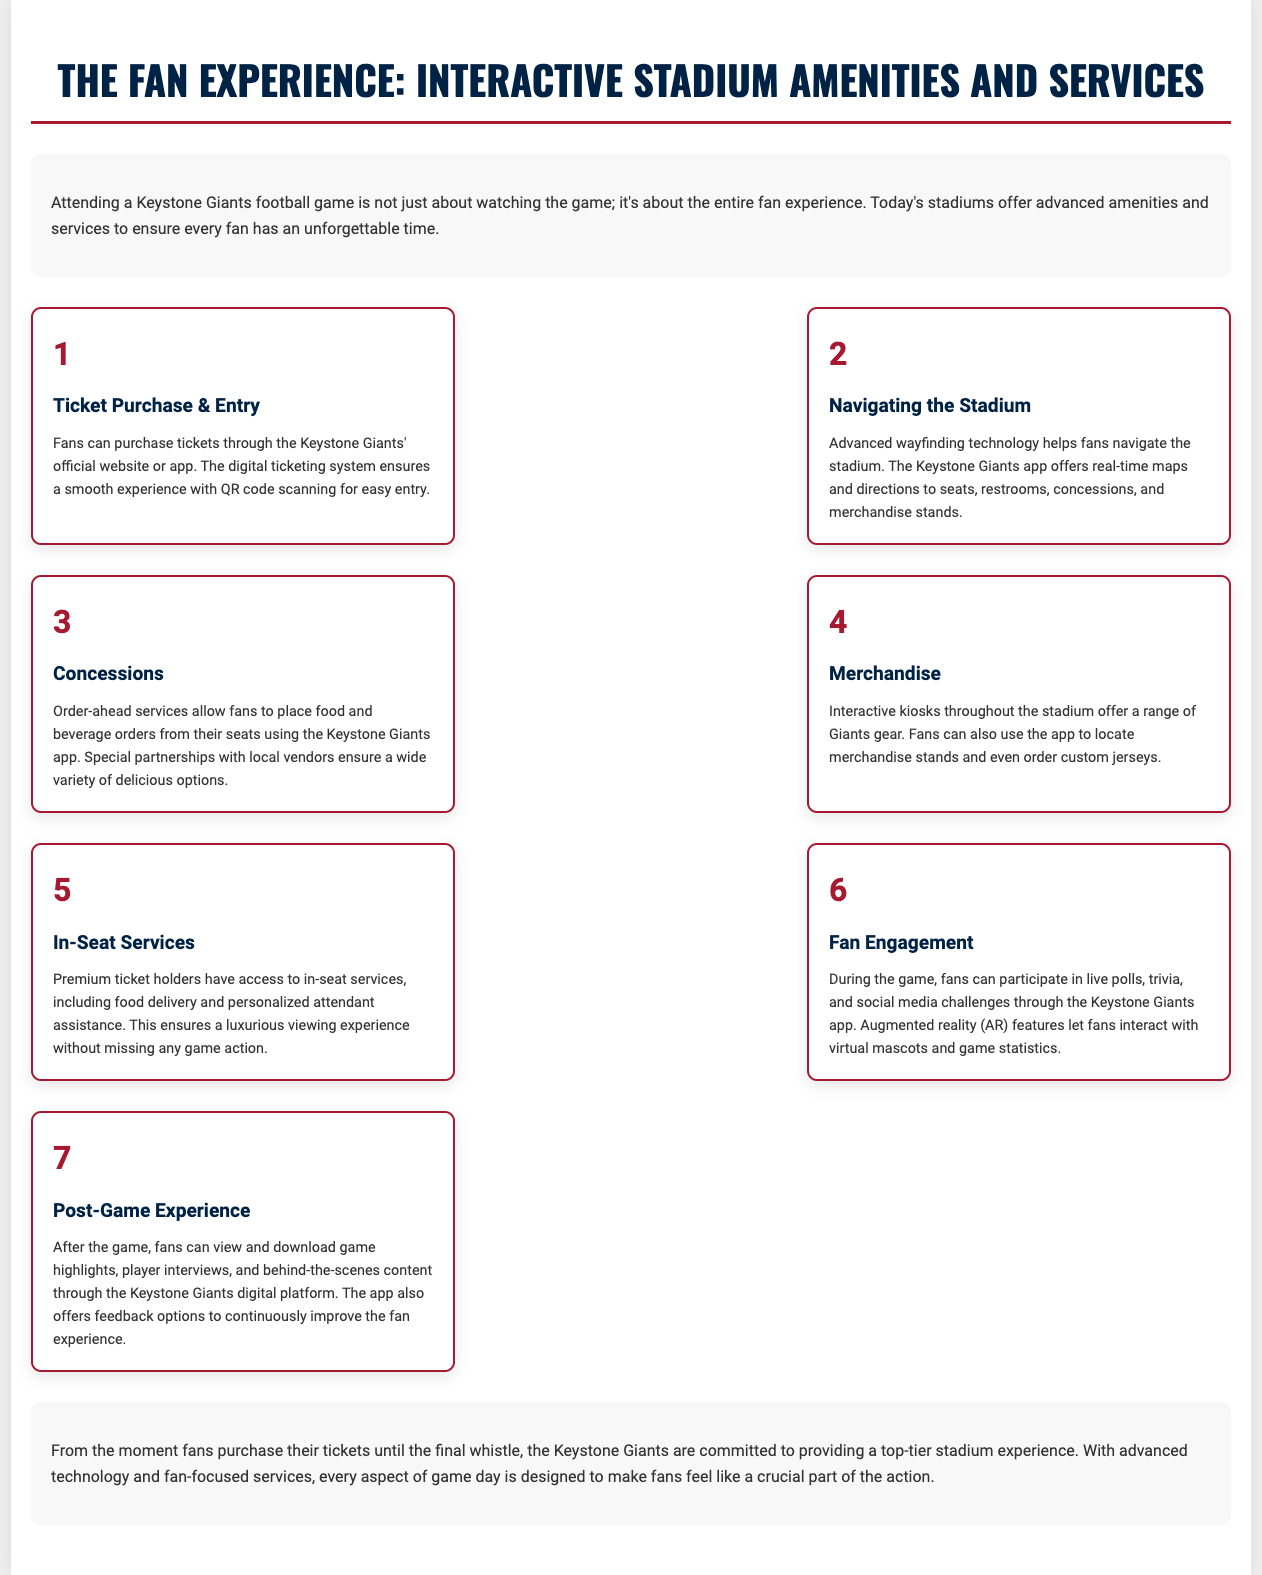what is the title of the document? The title of the document is prominently displayed at the top, indicating the primary subject matter.
Answer: The Fan Experience: Interactive Stadium Amenities and Services how many steps are included in the document? The document outlines a total of seven distinct steps related to the fan experience.
Answer: 7 what service allows fans to order food from their seats? The specific service that enables fans to place food orders directly from their seats is specified in the concessions section.
Answer: Order-ahead services which app is mentioned for navigation in the stadium? The app indicated for helping fans navigate the stadium is referenced under the navigating section.
Answer: Keystone Giants app what kind of experiences can fans participate in during the game? The document specifies various activities fans can engage in during the game that encourage interaction through the app.
Answer: live polls, trivia, and social media challenges what feature is available for premium ticket holders? The premium ticket holders have a unique service available to them that enhances their experience during the game.
Answer: in-seat services what is the post-game offering mentioned in the document? The document mentions what fans can access after the game, highlighting the content available for viewing.
Answer: game highlights, player interviews, and behind-the-scenes content how are fans encouraged to give feedback? The document outlines how fans can provide their opinions about the overall experience, ensuring continuous improvement.
Answer: feedback options 